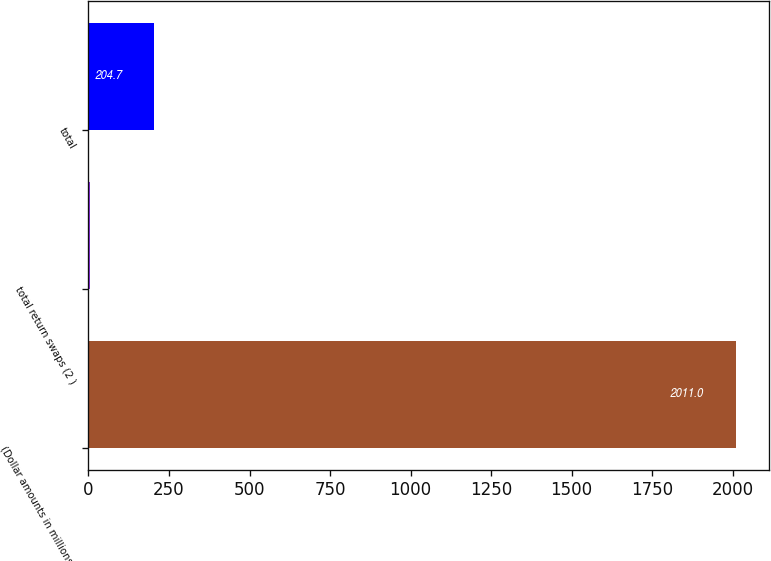<chart> <loc_0><loc_0><loc_500><loc_500><bar_chart><fcel>(Dollar amounts in millions)<fcel>total return swaps (2 )<fcel>total<nl><fcel>2011<fcel>4<fcel>204.7<nl></chart> 